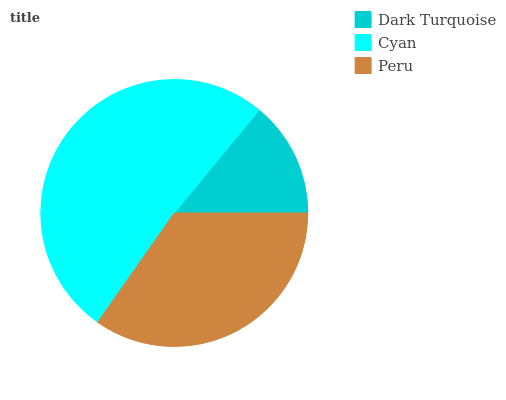Is Dark Turquoise the minimum?
Answer yes or no. Yes. Is Cyan the maximum?
Answer yes or no. Yes. Is Peru the minimum?
Answer yes or no. No. Is Peru the maximum?
Answer yes or no. No. Is Cyan greater than Peru?
Answer yes or no. Yes. Is Peru less than Cyan?
Answer yes or no. Yes. Is Peru greater than Cyan?
Answer yes or no. No. Is Cyan less than Peru?
Answer yes or no. No. Is Peru the high median?
Answer yes or no. Yes. Is Peru the low median?
Answer yes or no. Yes. Is Dark Turquoise the high median?
Answer yes or no. No. Is Cyan the low median?
Answer yes or no. No. 